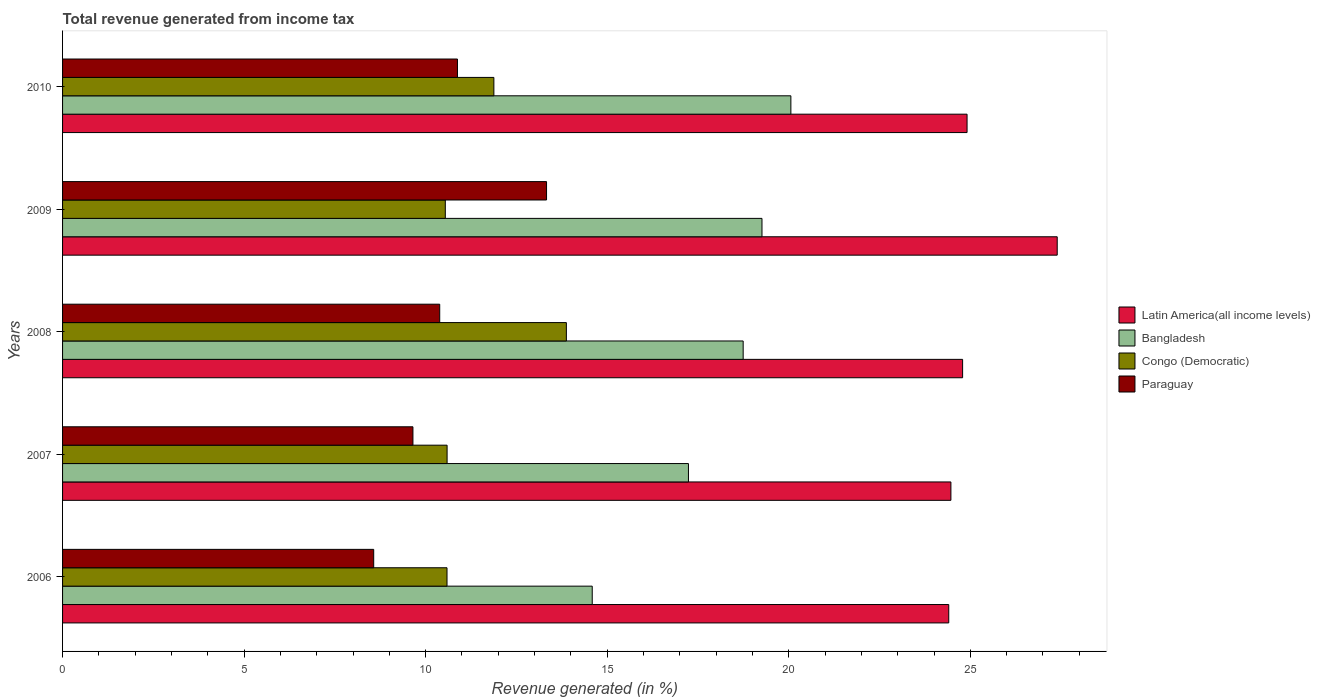How many different coloured bars are there?
Keep it short and to the point. 4. How many bars are there on the 3rd tick from the top?
Offer a very short reply. 4. How many bars are there on the 3rd tick from the bottom?
Your answer should be very brief. 4. What is the total revenue generated in Latin America(all income levels) in 2009?
Your response must be concise. 27.39. Across all years, what is the maximum total revenue generated in Paraguay?
Give a very brief answer. 13.33. Across all years, what is the minimum total revenue generated in Latin America(all income levels)?
Provide a succinct answer. 24.41. In which year was the total revenue generated in Congo (Democratic) minimum?
Offer a very short reply. 2009. What is the total total revenue generated in Latin America(all income levels) in the graph?
Offer a terse response. 125.96. What is the difference between the total revenue generated in Bangladesh in 2006 and that in 2010?
Keep it short and to the point. -5.47. What is the difference between the total revenue generated in Bangladesh in 2008 and the total revenue generated in Congo (Democratic) in 2007?
Make the answer very short. 8.15. What is the average total revenue generated in Paraguay per year?
Ensure brevity in your answer.  10.56. In the year 2009, what is the difference between the total revenue generated in Bangladesh and total revenue generated in Congo (Democratic)?
Your response must be concise. 8.72. In how many years, is the total revenue generated in Bangladesh greater than 11 %?
Your response must be concise. 5. What is the ratio of the total revenue generated in Paraguay in 2008 to that in 2009?
Your answer should be very brief. 0.78. Is the total revenue generated in Bangladesh in 2006 less than that in 2010?
Provide a short and direct response. Yes. What is the difference between the highest and the second highest total revenue generated in Latin America(all income levels)?
Your answer should be very brief. 2.48. What is the difference between the highest and the lowest total revenue generated in Congo (Democratic)?
Provide a short and direct response. 3.33. In how many years, is the total revenue generated in Bangladesh greater than the average total revenue generated in Bangladesh taken over all years?
Offer a very short reply. 3. What does the 1st bar from the top in 2009 represents?
Your response must be concise. Paraguay. Is it the case that in every year, the sum of the total revenue generated in Paraguay and total revenue generated in Latin America(all income levels) is greater than the total revenue generated in Bangladesh?
Ensure brevity in your answer.  Yes. Are all the bars in the graph horizontal?
Ensure brevity in your answer.  Yes. How many years are there in the graph?
Keep it short and to the point. 5. What is the difference between two consecutive major ticks on the X-axis?
Your answer should be compact. 5. Where does the legend appear in the graph?
Offer a terse response. Center right. How are the legend labels stacked?
Give a very brief answer. Vertical. What is the title of the graph?
Make the answer very short. Total revenue generated from income tax. Does "South Africa" appear as one of the legend labels in the graph?
Offer a very short reply. No. What is the label or title of the X-axis?
Make the answer very short. Revenue generated (in %). What is the Revenue generated (in %) of Latin America(all income levels) in 2006?
Give a very brief answer. 24.41. What is the Revenue generated (in %) of Bangladesh in 2006?
Your answer should be compact. 14.59. What is the Revenue generated (in %) in Congo (Democratic) in 2006?
Make the answer very short. 10.59. What is the Revenue generated (in %) in Paraguay in 2006?
Offer a terse response. 8.57. What is the Revenue generated (in %) of Latin America(all income levels) in 2007?
Keep it short and to the point. 24.47. What is the Revenue generated (in %) in Bangladesh in 2007?
Provide a succinct answer. 17.24. What is the Revenue generated (in %) in Congo (Democratic) in 2007?
Keep it short and to the point. 10.59. What is the Revenue generated (in %) in Paraguay in 2007?
Provide a succinct answer. 9.65. What is the Revenue generated (in %) of Latin America(all income levels) in 2008?
Make the answer very short. 24.79. What is the Revenue generated (in %) in Bangladesh in 2008?
Keep it short and to the point. 18.74. What is the Revenue generated (in %) of Congo (Democratic) in 2008?
Make the answer very short. 13.88. What is the Revenue generated (in %) of Paraguay in 2008?
Give a very brief answer. 10.39. What is the Revenue generated (in %) in Latin America(all income levels) in 2009?
Keep it short and to the point. 27.39. What is the Revenue generated (in %) of Bangladesh in 2009?
Offer a very short reply. 19.26. What is the Revenue generated (in %) in Congo (Democratic) in 2009?
Offer a terse response. 10.54. What is the Revenue generated (in %) of Paraguay in 2009?
Offer a terse response. 13.33. What is the Revenue generated (in %) of Latin America(all income levels) in 2010?
Provide a short and direct response. 24.91. What is the Revenue generated (in %) of Bangladesh in 2010?
Offer a terse response. 20.06. What is the Revenue generated (in %) in Congo (Democratic) in 2010?
Your answer should be compact. 11.88. What is the Revenue generated (in %) of Paraguay in 2010?
Your answer should be very brief. 10.88. Across all years, what is the maximum Revenue generated (in %) of Latin America(all income levels)?
Provide a succinct answer. 27.39. Across all years, what is the maximum Revenue generated (in %) in Bangladesh?
Offer a very short reply. 20.06. Across all years, what is the maximum Revenue generated (in %) of Congo (Democratic)?
Your answer should be compact. 13.88. Across all years, what is the maximum Revenue generated (in %) of Paraguay?
Ensure brevity in your answer.  13.33. Across all years, what is the minimum Revenue generated (in %) in Latin America(all income levels)?
Give a very brief answer. 24.41. Across all years, what is the minimum Revenue generated (in %) of Bangladesh?
Give a very brief answer. 14.59. Across all years, what is the minimum Revenue generated (in %) in Congo (Democratic)?
Keep it short and to the point. 10.54. Across all years, what is the minimum Revenue generated (in %) of Paraguay?
Ensure brevity in your answer.  8.57. What is the total Revenue generated (in %) of Latin America(all income levels) in the graph?
Keep it short and to the point. 125.96. What is the total Revenue generated (in %) in Bangladesh in the graph?
Keep it short and to the point. 89.89. What is the total Revenue generated (in %) in Congo (Democratic) in the graph?
Your answer should be very brief. 57.47. What is the total Revenue generated (in %) of Paraguay in the graph?
Offer a terse response. 52.81. What is the difference between the Revenue generated (in %) of Latin America(all income levels) in 2006 and that in 2007?
Offer a terse response. -0.06. What is the difference between the Revenue generated (in %) of Bangladesh in 2006 and that in 2007?
Offer a terse response. -2.65. What is the difference between the Revenue generated (in %) of Congo (Democratic) in 2006 and that in 2007?
Offer a very short reply. -0. What is the difference between the Revenue generated (in %) of Paraguay in 2006 and that in 2007?
Give a very brief answer. -1.08. What is the difference between the Revenue generated (in %) of Latin America(all income levels) in 2006 and that in 2008?
Your answer should be very brief. -0.38. What is the difference between the Revenue generated (in %) in Bangladesh in 2006 and that in 2008?
Provide a succinct answer. -4.16. What is the difference between the Revenue generated (in %) in Congo (Democratic) in 2006 and that in 2008?
Keep it short and to the point. -3.29. What is the difference between the Revenue generated (in %) of Paraguay in 2006 and that in 2008?
Provide a succinct answer. -1.82. What is the difference between the Revenue generated (in %) of Latin America(all income levels) in 2006 and that in 2009?
Make the answer very short. -2.99. What is the difference between the Revenue generated (in %) of Bangladesh in 2006 and that in 2009?
Your answer should be compact. -4.67. What is the difference between the Revenue generated (in %) in Congo (Democratic) in 2006 and that in 2009?
Offer a very short reply. 0.05. What is the difference between the Revenue generated (in %) of Paraguay in 2006 and that in 2009?
Offer a terse response. -4.76. What is the difference between the Revenue generated (in %) in Latin America(all income levels) in 2006 and that in 2010?
Offer a terse response. -0.5. What is the difference between the Revenue generated (in %) in Bangladesh in 2006 and that in 2010?
Offer a very short reply. -5.47. What is the difference between the Revenue generated (in %) in Congo (Democratic) in 2006 and that in 2010?
Your answer should be compact. -1.29. What is the difference between the Revenue generated (in %) of Paraguay in 2006 and that in 2010?
Make the answer very short. -2.31. What is the difference between the Revenue generated (in %) of Latin America(all income levels) in 2007 and that in 2008?
Make the answer very short. -0.32. What is the difference between the Revenue generated (in %) of Bangladesh in 2007 and that in 2008?
Make the answer very short. -1.51. What is the difference between the Revenue generated (in %) in Congo (Democratic) in 2007 and that in 2008?
Your answer should be very brief. -3.28. What is the difference between the Revenue generated (in %) in Paraguay in 2007 and that in 2008?
Make the answer very short. -0.74. What is the difference between the Revenue generated (in %) in Latin America(all income levels) in 2007 and that in 2009?
Offer a terse response. -2.93. What is the difference between the Revenue generated (in %) of Bangladesh in 2007 and that in 2009?
Provide a succinct answer. -2.03. What is the difference between the Revenue generated (in %) of Congo (Democratic) in 2007 and that in 2009?
Your response must be concise. 0.05. What is the difference between the Revenue generated (in %) of Paraguay in 2007 and that in 2009?
Your answer should be compact. -3.68. What is the difference between the Revenue generated (in %) of Latin America(all income levels) in 2007 and that in 2010?
Offer a very short reply. -0.44. What is the difference between the Revenue generated (in %) of Bangladesh in 2007 and that in 2010?
Make the answer very short. -2.82. What is the difference between the Revenue generated (in %) of Congo (Democratic) in 2007 and that in 2010?
Offer a terse response. -1.29. What is the difference between the Revenue generated (in %) of Paraguay in 2007 and that in 2010?
Your answer should be very brief. -1.23. What is the difference between the Revenue generated (in %) in Latin America(all income levels) in 2008 and that in 2009?
Make the answer very short. -2.61. What is the difference between the Revenue generated (in %) in Bangladesh in 2008 and that in 2009?
Your answer should be compact. -0.52. What is the difference between the Revenue generated (in %) in Congo (Democratic) in 2008 and that in 2009?
Offer a terse response. 3.33. What is the difference between the Revenue generated (in %) in Paraguay in 2008 and that in 2009?
Ensure brevity in your answer.  -2.94. What is the difference between the Revenue generated (in %) in Latin America(all income levels) in 2008 and that in 2010?
Your answer should be compact. -0.12. What is the difference between the Revenue generated (in %) of Bangladesh in 2008 and that in 2010?
Your answer should be very brief. -1.31. What is the difference between the Revenue generated (in %) of Congo (Democratic) in 2008 and that in 2010?
Keep it short and to the point. 2. What is the difference between the Revenue generated (in %) in Paraguay in 2008 and that in 2010?
Make the answer very short. -0.49. What is the difference between the Revenue generated (in %) in Latin America(all income levels) in 2009 and that in 2010?
Give a very brief answer. 2.48. What is the difference between the Revenue generated (in %) in Bangladesh in 2009 and that in 2010?
Offer a terse response. -0.8. What is the difference between the Revenue generated (in %) in Congo (Democratic) in 2009 and that in 2010?
Provide a succinct answer. -1.34. What is the difference between the Revenue generated (in %) in Paraguay in 2009 and that in 2010?
Ensure brevity in your answer.  2.45. What is the difference between the Revenue generated (in %) in Latin America(all income levels) in 2006 and the Revenue generated (in %) in Bangladesh in 2007?
Your answer should be very brief. 7.17. What is the difference between the Revenue generated (in %) in Latin America(all income levels) in 2006 and the Revenue generated (in %) in Congo (Democratic) in 2007?
Offer a terse response. 13.82. What is the difference between the Revenue generated (in %) in Latin America(all income levels) in 2006 and the Revenue generated (in %) in Paraguay in 2007?
Your answer should be compact. 14.76. What is the difference between the Revenue generated (in %) in Bangladesh in 2006 and the Revenue generated (in %) in Congo (Democratic) in 2007?
Your answer should be very brief. 4. What is the difference between the Revenue generated (in %) of Bangladesh in 2006 and the Revenue generated (in %) of Paraguay in 2007?
Offer a very short reply. 4.94. What is the difference between the Revenue generated (in %) of Congo (Democratic) in 2006 and the Revenue generated (in %) of Paraguay in 2007?
Your response must be concise. 0.94. What is the difference between the Revenue generated (in %) in Latin America(all income levels) in 2006 and the Revenue generated (in %) in Bangladesh in 2008?
Provide a short and direct response. 5.66. What is the difference between the Revenue generated (in %) of Latin America(all income levels) in 2006 and the Revenue generated (in %) of Congo (Democratic) in 2008?
Make the answer very short. 10.53. What is the difference between the Revenue generated (in %) of Latin America(all income levels) in 2006 and the Revenue generated (in %) of Paraguay in 2008?
Keep it short and to the point. 14.02. What is the difference between the Revenue generated (in %) of Bangladesh in 2006 and the Revenue generated (in %) of Congo (Democratic) in 2008?
Keep it short and to the point. 0.71. What is the difference between the Revenue generated (in %) in Bangladesh in 2006 and the Revenue generated (in %) in Paraguay in 2008?
Provide a short and direct response. 4.2. What is the difference between the Revenue generated (in %) of Congo (Democratic) in 2006 and the Revenue generated (in %) of Paraguay in 2008?
Your response must be concise. 0.2. What is the difference between the Revenue generated (in %) of Latin America(all income levels) in 2006 and the Revenue generated (in %) of Bangladesh in 2009?
Provide a succinct answer. 5.14. What is the difference between the Revenue generated (in %) of Latin America(all income levels) in 2006 and the Revenue generated (in %) of Congo (Democratic) in 2009?
Give a very brief answer. 13.87. What is the difference between the Revenue generated (in %) in Latin America(all income levels) in 2006 and the Revenue generated (in %) in Paraguay in 2009?
Provide a short and direct response. 11.08. What is the difference between the Revenue generated (in %) in Bangladesh in 2006 and the Revenue generated (in %) in Congo (Democratic) in 2009?
Keep it short and to the point. 4.05. What is the difference between the Revenue generated (in %) of Bangladesh in 2006 and the Revenue generated (in %) of Paraguay in 2009?
Give a very brief answer. 1.26. What is the difference between the Revenue generated (in %) in Congo (Democratic) in 2006 and the Revenue generated (in %) in Paraguay in 2009?
Offer a terse response. -2.74. What is the difference between the Revenue generated (in %) in Latin America(all income levels) in 2006 and the Revenue generated (in %) in Bangladesh in 2010?
Your answer should be very brief. 4.35. What is the difference between the Revenue generated (in %) of Latin America(all income levels) in 2006 and the Revenue generated (in %) of Congo (Democratic) in 2010?
Provide a short and direct response. 12.53. What is the difference between the Revenue generated (in %) of Latin America(all income levels) in 2006 and the Revenue generated (in %) of Paraguay in 2010?
Give a very brief answer. 13.53. What is the difference between the Revenue generated (in %) in Bangladesh in 2006 and the Revenue generated (in %) in Congo (Democratic) in 2010?
Give a very brief answer. 2.71. What is the difference between the Revenue generated (in %) in Bangladesh in 2006 and the Revenue generated (in %) in Paraguay in 2010?
Offer a very short reply. 3.71. What is the difference between the Revenue generated (in %) in Congo (Democratic) in 2006 and the Revenue generated (in %) in Paraguay in 2010?
Keep it short and to the point. -0.29. What is the difference between the Revenue generated (in %) of Latin America(all income levels) in 2007 and the Revenue generated (in %) of Bangladesh in 2008?
Your answer should be very brief. 5.72. What is the difference between the Revenue generated (in %) in Latin America(all income levels) in 2007 and the Revenue generated (in %) in Congo (Democratic) in 2008?
Make the answer very short. 10.59. What is the difference between the Revenue generated (in %) in Latin America(all income levels) in 2007 and the Revenue generated (in %) in Paraguay in 2008?
Keep it short and to the point. 14.08. What is the difference between the Revenue generated (in %) in Bangladesh in 2007 and the Revenue generated (in %) in Congo (Democratic) in 2008?
Your answer should be very brief. 3.36. What is the difference between the Revenue generated (in %) in Bangladesh in 2007 and the Revenue generated (in %) in Paraguay in 2008?
Make the answer very short. 6.85. What is the difference between the Revenue generated (in %) in Congo (Democratic) in 2007 and the Revenue generated (in %) in Paraguay in 2008?
Keep it short and to the point. 0.2. What is the difference between the Revenue generated (in %) of Latin America(all income levels) in 2007 and the Revenue generated (in %) of Bangladesh in 2009?
Provide a succinct answer. 5.2. What is the difference between the Revenue generated (in %) in Latin America(all income levels) in 2007 and the Revenue generated (in %) in Congo (Democratic) in 2009?
Your answer should be compact. 13.92. What is the difference between the Revenue generated (in %) in Latin America(all income levels) in 2007 and the Revenue generated (in %) in Paraguay in 2009?
Your answer should be very brief. 11.14. What is the difference between the Revenue generated (in %) of Bangladesh in 2007 and the Revenue generated (in %) of Congo (Democratic) in 2009?
Your answer should be compact. 6.7. What is the difference between the Revenue generated (in %) in Bangladesh in 2007 and the Revenue generated (in %) in Paraguay in 2009?
Ensure brevity in your answer.  3.91. What is the difference between the Revenue generated (in %) of Congo (Democratic) in 2007 and the Revenue generated (in %) of Paraguay in 2009?
Provide a succinct answer. -2.74. What is the difference between the Revenue generated (in %) in Latin America(all income levels) in 2007 and the Revenue generated (in %) in Bangladesh in 2010?
Make the answer very short. 4.41. What is the difference between the Revenue generated (in %) in Latin America(all income levels) in 2007 and the Revenue generated (in %) in Congo (Democratic) in 2010?
Your answer should be compact. 12.59. What is the difference between the Revenue generated (in %) of Latin America(all income levels) in 2007 and the Revenue generated (in %) of Paraguay in 2010?
Your answer should be compact. 13.59. What is the difference between the Revenue generated (in %) in Bangladesh in 2007 and the Revenue generated (in %) in Congo (Democratic) in 2010?
Make the answer very short. 5.36. What is the difference between the Revenue generated (in %) in Bangladesh in 2007 and the Revenue generated (in %) in Paraguay in 2010?
Offer a terse response. 6.36. What is the difference between the Revenue generated (in %) of Congo (Democratic) in 2007 and the Revenue generated (in %) of Paraguay in 2010?
Offer a terse response. -0.29. What is the difference between the Revenue generated (in %) in Latin America(all income levels) in 2008 and the Revenue generated (in %) in Bangladesh in 2009?
Offer a terse response. 5.53. What is the difference between the Revenue generated (in %) of Latin America(all income levels) in 2008 and the Revenue generated (in %) of Congo (Democratic) in 2009?
Provide a succinct answer. 14.25. What is the difference between the Revenue generated (in %) in Latin America(all income levels) in 2008 and the Revenue generated (in %) in Paraguay in 2009?
Provide a succinct answer. 11.46. What is the difference between the Revenue generated (in %) in Bangladesh in 2008 and the Revenue generated (in %) in Congo (Democratic) in 2009?
Make the answer very short. 8.2. What is the difference between the Revenue generated (in %) in Bangladesh in 2008 and the Revenue generated (in %) in Paraguay in 2009?
Give a very brief answer. 5.42. What is the difference between the Revenue generated (in %) of Congo (Democratic) in 2008 and the Revenue generated (in %) of Paraguay in 2009?
Provide a short and direct response. 0.55. What is the difference between the Revenue generated (in %) in Latin America(all income levels) in 2008 and the Revenue generated (in %) in Bangladesh in 2010?
Your answer should be very brief. 4.73. What is the difference between the Revenue generated (in %) of Latin America(all income levels) in 2008 and the Revenue generated (in %) of Congo (Democratic) in 2010?
Ensure brevity in your answer.  12.91. What is the difference between the Revenue generated (in %) of Latin America(all income levels) in 2008 and the Revenue generated (in %) of Paraguay in 2010?
Make the answer very short. 13.91. What is the difference between the Revenue generated (in %) of Bangladesh in 2008 and the Revenue generated (in %) of Congo (Democratic) in 2010?
Provide a short and direct response. 6.87. What is the difference between the Revenue generated (in %) of Bangladesh in 2008 and the Revenue generated (in %) of Paraguay in 2010?
Provide a succinct answer. 7.87. What is the difference between the Revenue generated (in %) in Congo (Democratic) in 2008 and the Revenue generated (in %) in Paraguay in 2010?
Your response must be concise. 3. What is the difference between the Revenue generated (in %) of Latin America(all income levels) in 2009 and the Revenue generated (in %) of Bangladesh in 2010?
Make the answer very short. 7.33. What is the difference between the Revenue generated (in %) of Latin America(all income levels) in 2009 and the Revenue generated (in %) of Congo (Democratic) in 2010?
Ensure brevity in your answer.  15.51. What is the difference between the Revenue generated (in %) of Latin America(all income levels) in 2009 and the Revenue generated (in %) of Paraguay in 2010?
Keep it short and to the point. 16.52. What is the difference between the Revenue generated (in %) in Bangladesh in 2009 and the Revenue generated (in %) in Congo (Democratic) in 2010?
Provide a short and direct response. 7.38. What is the difference between the Revenue generated (in %) of Bangladesh in 2009 and the Revenue generated (in %) of Paraguay in 2010?
Keep it short and to the point. 8.39. What is the difference between the Revenue generated (in %) of Congo (Democratic) in 2009 and the Revenue generated (in %) of Paraguay in 2010?
Your answer should be compact. -0.34. What is the average Revenue generated (in %) of Latin America(all income levels) per year?
Keep it short and to the point. 25.19. What is the average Revenue generated (in %) in Bangladesh per year?
Provide a short and direct response. 17.98. What is the average Revenue generated (in %) of Congo (Democratic) per year?
Your answer should be compact. 11.49. What is the average Revenue generated (in %) of Paraguay per year?
Ensure brevity in your answer.  10.56. In the year 2006, what is the difference between the Revenue generated (in %) of Latin America(all income levels) and Revenue generated (in %) of Bangladesh?
Your answer should be compact. 9.82. In the year 2006, what is the difference between the Revenue generated (in %) of Latin America(all income levels) and Revenue generated (in %) of Congo (Democratic)?
Give a very brief answer. 13.82. In the year 2006, what is the difference between the Revenue generated (in %) in Latin America(all income levels) and Revenue generated (in %) in Paraguay?
Your answer should be very brief. 15.84. In the year 2006, what is the difference between the Revenue generated (in %) in Bangladesh and Revenue generated (in %) in Congo (Democratic)?
Make the answer very short. 4. In the year 2006, what is the difference between the Revenue generated (in %) of Bangladesh and Revenue generated (in %) of Paraguay?
Ensure brevity in your answer.  6.02. In the year 2006, what is the difference between the Revenue generated (in %) in Congo (Democratic) and Revenue generated (in %) in Paraguay?
Offer a very short reply. 2.02. In the year 2007, what is the difference between the Revenue generated (in %) of Latin America(all income levels) and Revenue generated (in %) of Bangladesh?
Your answer should be very brief. 7.23. In the year 2007, what is the difference between the Revenue generated (in %) in Latin America(all income levels) and Revenue generated (in %) in Congo (Democratic)?
Your answer should be very brief. 13.88. In the year 2007, what is the difference between the Revenue generated (in %) in Latin America(all income levels) and Revenue generated (in %) in Paraguay?
Provide a succinct answer. 14.82. In the year 2007, what is the difference between the Revenue generated (in %) in Bangladesh and Revenue generated (in %) in Congo (Democratic)?
Your answer should be compact. 6.65. In the year 2007, what is the difference between the Revenue generated (in %) of Bangladesh and Revenue generated (in %) of Paraguay?
Provide a succinct answer. 7.59. In the year 2007, what is the difference between the Revenue generated (in %) of Congo (Democratic) and Revenue generated (in %) of Paraguay?
Your response must be concise. 0.94. In the year 2008, what is the difference between the Revenue generated (in %) in Latin America(all income levels) and Revenue generated (in %) in Bangladesh?
Offer a very short reply. 6.04. In the year 2008, what is the difference between the Revenue generated (in %) of Latin America(all income levels) and Revenue generated (in %) of Congo (Democratic)?
Your answer should be very brief. 10.91. In the year 2008, what is the difference between the Revenue generated (in %) of Latin America(all income levels) and Revenue generated (in %) of Paraguay?
Provide a short and direct response. 14.4. In the year 2008, what is the difference between the Revenue generated (in %) in Bangladesh and Revenue generated (in %) in Congo (Democratic)?
Provide a short and direct response. 4.87. In the year 2008, what is the difference between the Revenue generated (in %) in Bangladesh and Revenue generated (in %) in Paraguay?
Provide a succinct answer. 8.36. In the year 2008, what is the difference between the Revenue generated (in %) of Congo (Democratic) and Revenue generated (in %) of Paraguay?
Offer a very short reply. 3.49. In the year 2009, what is the difference between the Revenue generated (in %) of Latin America(all income levels) and Revenue generated (in %) of Bangladesh?
Your answer should be very brief. 8.13. In the year 2009, what is the difference between the Revenue generated (in %) of Latin America(all income levels) and Revenue generated (in %) of Congo (Democratic)?
Offer a very short reply. 16.85. In the year 2009, what is the difference between the Revenue generated (in %) in Latin America(all income levels) and Revenue generated (in %) in Paraguay?
Your answer should be very brief. 14.06. In the year 2009, what is the difference between the Revenue generated (in %) in Bangladesh and Revenue generated (in %) in Congo (Democratic)?
Your response must be concise. 8.72. In the year 2009, what is the difference between the Revenue generated (in %) of Bangladesh and Revenue generated (in %) of Paraguay?
Offer a terse response. 5.93. In the year 2009, what is the difference between the Revenue generated (in %) in Congo (Democratic) and Revenue generated (in %) in Paraguay?
Your answer should be compact. -2.79. In the year 2010, what is the difference between the Revenue generated (in %) in Latin America(all income levels) and Revenue generated (in %) in Bangladesh?
Your response must be concise. 4.85. In the year 2010, what is the difference between the Revenue generated (in %) in Latin America(all income levels) and Revenue generated (in %) in Congo (Democratic)?
Your answer should be compact. 13.03. In the year 2010, what is the difference between the Revenue generated (in %) of Latin America(all income levels) and Revenue generated (in %) of Paraguay?
Your response must be concise. 14.03. In the year 2010, what is the difference between the Revenue generated (in %) in Bangladesh and Revenue generated (in %) in Congo (Democratic)?
Your answer should be compact. 8.18. In the year 2010, what is the difference between the Revenue generated (in %) of Bangladesh and Revenue generated (in %) of Paraguay?
Provide a succinct answer. 9.18. What is the ratio of the Revenue generated (in %) in Latin America(all income levels) in 2006 to that in 2007?
Ensure brevity in your answer.  1. What is the ratio of the Revenue generated (in %) in Bangladesh in 2006 to that in 2007?
Offer a terse response. 0.85. What is the ratio of the Revenue generated (in %) in Congo (Democratic) in 2006 to that in 2007?
Keep it short and to the point. 1. What is the ratio of the Revenue generated (in %) in Paraguay in 2006 to that in 2007?
Give a very brief answer. 0.89. What is the ratio of the Revenue generated (in %) in Latin America(all income levels) in 2006 to that in 2008?
Your response must be concise. 0.98. What is the ratio of the Revenue generated (in %) of Bangladesh in 2006 to that in 2008?
Offer a very short reply. 0.78. What is the ratio of the Revenue generated (in %) of Congo (Democratic) in 2006 to that in 2008?
Provide a succinct answer. 0.76. What is the ratio of the Revenue generated (in %) in Paraguay in 2006 to that in 2008?
Offer a very short reply. 0.82. What is the ratio of the Revenue generated (in %) of Latin America(all income levels) in 2006 to that in 2009?
Keep it short and to the point. 0.89. What is the ratio of the Revenue generated (in %) of Bangladesh in 2006 to that in 2009?
Provide a succinct answer. 0.76. What is the ratio of the Revenue generated (in %) of Paraguay in 2006 to that in 2009?
Your response must be concise. 0.64. What is the ratio of the Revenue generated (in %) of Latin America(all income levels) in 2006 to that in 2010?
Ensure brevity in your answer.  0.98. What is the ratio of the Revenue generated (in %) in Bangladesh in 2006 to that in 2010?
Provide a succinct answer. 0.73. What is the ratio of the Revenue generated (in %) in Congo (Democratic) in 2006 to that in 2010?
Provide a succinct answer. 0.89. What is the ratio of the Revenue generated (in %) in Paraguay in 2006 to that in 2010?
Provide a succinct answer. 0.79. What is the ratio of the Revenue generated (in %) of Latin America(all income levels) in 2007 to that in 2008?
Your response must be concise. 0.99. What is the ratio of the Revenue generated (in %) of Bangladesh in 2007 to that in 2008?
Your answer should be compact. 0.92. What is the ratio of the Revenue generated (in %) of Congo (Democratic) in 2007 to that in 2008?
Your response must be concise. 0.76. What is the ratio of the Revenue generated (in %) of Paraguay in 2007 to that in 2008?
Provide a short and direct response. 0.93. What is the ratio of the Revenue generated (in %) of Latin America(all income levels) in 2007 to that in 2009?
Your response must be concise. 0.89. What is the ratio of the Revenue generated (in %) of Bangladesh in 2007 to that in 2009?
Provide a short and direct response. 0.89. What is the ratio of the Revenue generated (in %) of Paraguay in 2007 to that in 2009?
Offer a very short reply. 0.72. What is the ratio of the Revenue generated (in %) in Latin America(all income levels) in 2007 to that in 2010?
Ensure brevity in your answer.  0.98. What is the ratio of the Revenue generated (in %) in Bangladesh in 2007 to that in 2010?
Ensure brevity in your answer.  0.86. What is the ratio of the Revenue generated (in %) in Congo (Democratic) in 2007 to that in 2010?
Ensure brevity in your answer.  0.89. What is the ratio of the Revenue generated (in %) in Paraguay in 2007 to that in 2010?
Your response must be concise. 0.89. What is the ratio of the Revenue generated (in %) of Latin America(all income levels) in 2008 to that in 2009?
Make the answer very short. 0.9. What is the ratio of the Revenue generated (in %) in Bangladesh in 2008 to that in 2009?
Offer a terse response. 0.97. What is the ratio of the Revenue generated (in %) in Congo (Democratic) in 2008 to that in 2009?
Give a very brief answer. 1.32. What is the ratio of the Revenue generated (in %) of Paraguay in 2008 to that in 2009?
Offer a terse response. 0.78. What is the ratio of the Revenue generated (in %) in Latin America(all income levels) in 2008 to that in 2010?
Your answer should be compact. 1. What is the ratio of the Revenue generated (in %) of Bangladesh in 2008 to that in 2010?
Provide a succinct answer. 0.93. What is the ratio of the Revenue generated (in %) of Congo (Democratic) in 2008 to that in 2010?
Give a very brief answer. 1.17. What is the ratio of the Revenue generated (in %) of Paraguay in 2008 to that in 2010?
Ensure brevity in your answer.  0.95. What is the ratio of the Revenue generated (in %) in Latin America(all income levels) in 2009 to that in 2010?
Your answer should be compact. 1.1. What is the ratio of the Revenue generated (in %) of Bangladesh in 2009 to that in 2010?
Provide a short and direct response. 0.96. What is the ratio of the Revenue generated (in %) in Congo (Democratic) in 2009 to that in 2010?
Provide a succinct answer. 0.89. What is the ratio of the Revenue generated (in %) of Paraguay in 2009 to that in 2010?
Provide a short and direct response. 1.23. What is the difference between the highest and the second highest Revenue generated (in %) in Latin America(all income levels)?
Your response must be concise. 2.48. What is the difference between the highest and the second highest Revenue generated (in %) of Bangladesh?
Keep it short and to the point. 0.8. What is the difference between the highest and the second highest Revenue generated (in %) of Congo (Democratic)?
Provide a short and direct response. 2. What is the difference between the highest and the second highest Revenue generated (in %) of Paraguay?
Make the answer very short. 2.45. What is the difference between the highest and the lowest Revenue generated (in %) in Latin America(all income levels)?
Ensure brevity in your answer.  2.99. What is the difference between the highest and the lowest Revenue generated (in %) in Bangladesh?
Give a very brief answer. 5.47. What is the difference between the highest and the lowest Revenue generated (in %) in Congo (Democratic)?
Give a very brief answer. 3.33. What is the difference between the highest and the lowest Revenue generated (in %) in Paraguay?
Make the answer very short. 4.76. 